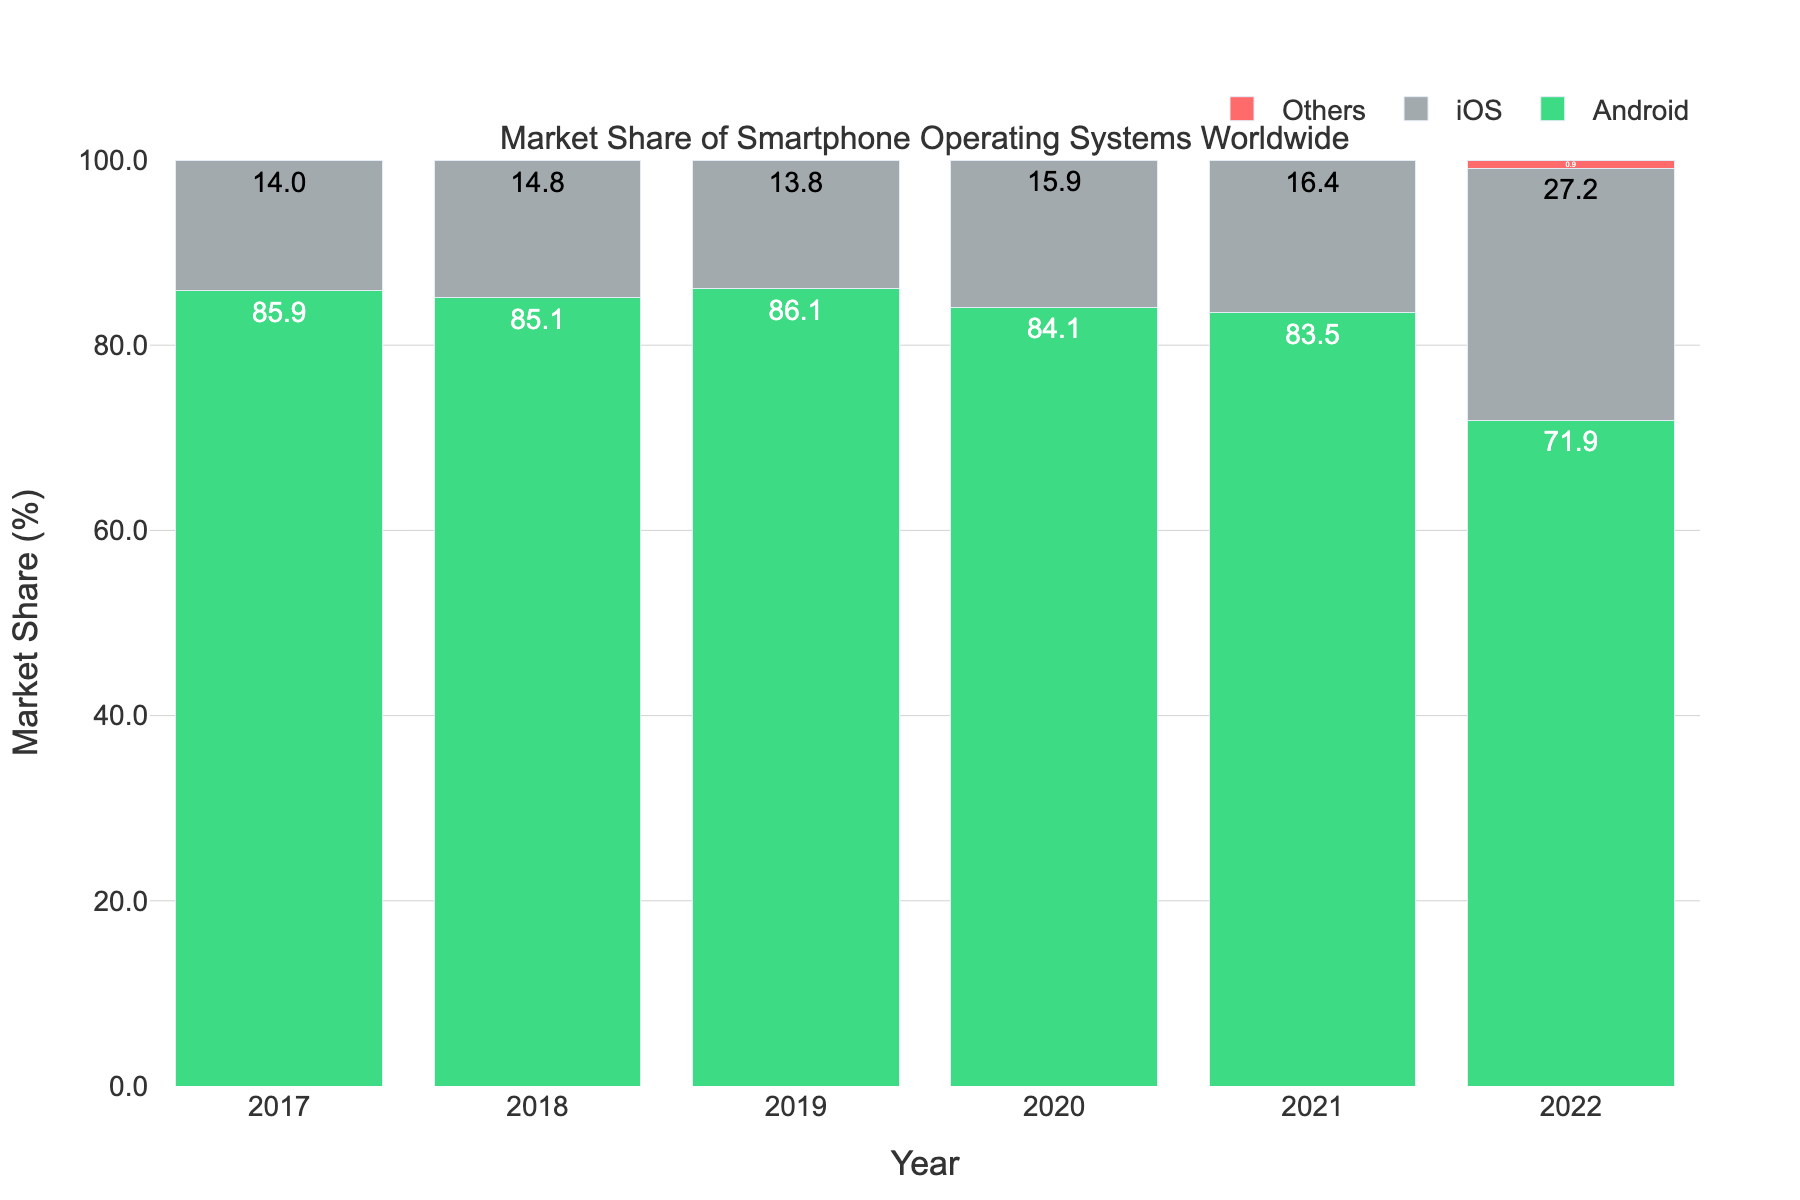What's the market share of Android in 2019? Look at the bar marked for Android in 2019 and read the corresponding value.
Answer: 86.1 What is the combined market share of iOS and Others in 2022? Add the market share values of iOS and Others in 2022: 27.2 (iOS) + 0.9 (Others) = 28.1
Answer: 28.1 Which year shows the highest market share for iOS? Identify the highest value for iOS across all years and then note the corresponding year.
Answer: 2022 Did the market share of Android increase or decrease from 2018 to 2019? Compare the Android market share values for 2018 (85.1%) and 2019 (86.1%). The value increased from 85.1% to 86.1%.
Answer: Increase By how much did the market share for Others change between 2021 and 2022? Calculate the difference between the market share for Others in 2022 and 2021: 0.9 - 0.1 = 0.8
Answer: 0.8 What’s the average market share of Android over the shown years? Add the market share of Android for all years 85.9 + 85.1 + 86.1 + 84.1 + 83.5 + 71.9 = 496.6, then divide by the number of years (6): 496.6 / 6 = 82.77
Answer: 82.77 Which year shows the lowest market share for Android? Identify the lowest value for Android across all years and then note the corresponding year.
Answer: 2022 What is the overall trend in the market share of iOS from 2017 to 2022? Observe the iOS bar values from 2017 to 2022 and note whether they generally increase, decrease, or stay the same. The values increase from 14.0% to 27.2%.
Answer: Increase How did the market share of iOS change from 2020 to 2021? Observe the iOS bar values for 2020 (15.9) and 2021 (16.4). Calculate the difference: 16.4 - 15.9 = 0.5.
Answer: 0.5 Which year had the smallest overall market share for smartphones categorized as Others? Identify the lowest overall market share value for Others across all years. In 2020, the others category has 0.0 market share.
Answer: 2020 